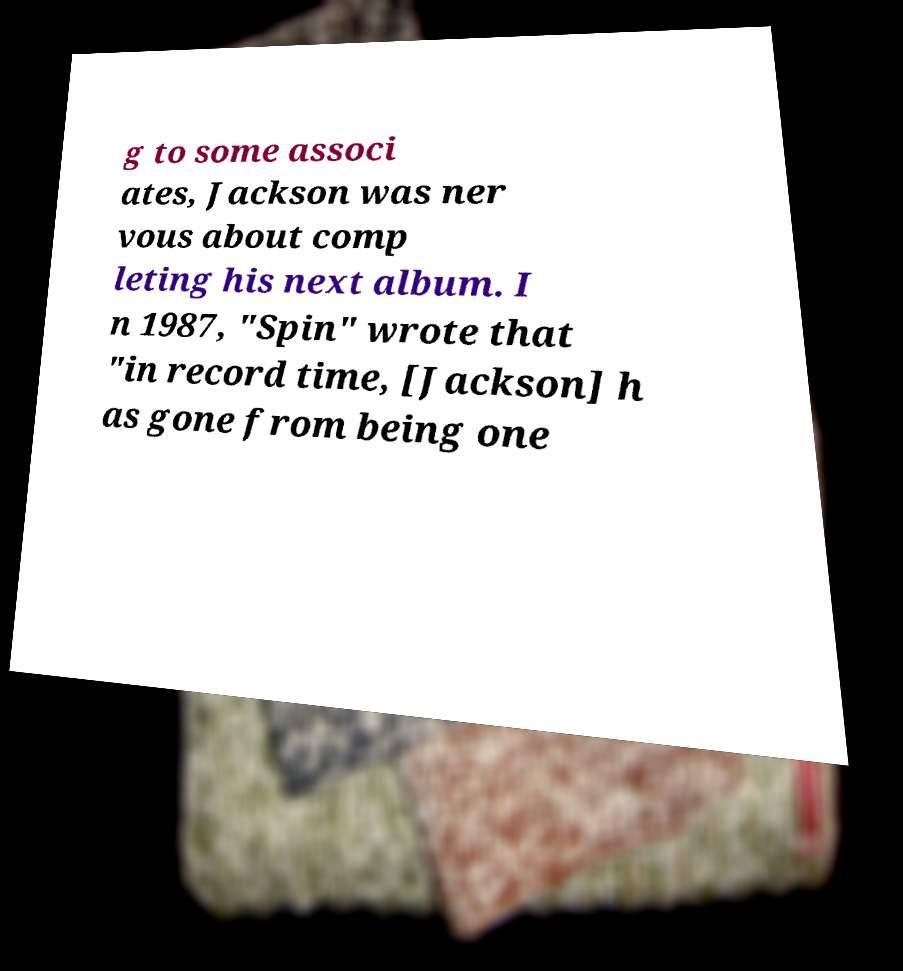Can you accurately transcribe the text from the provided image for me? g to some associ ates, Jackson was ner vous about comp leting his next album. I n 1987, "Spin" wrote that "in record time, [Jackson] h as gone from being one 